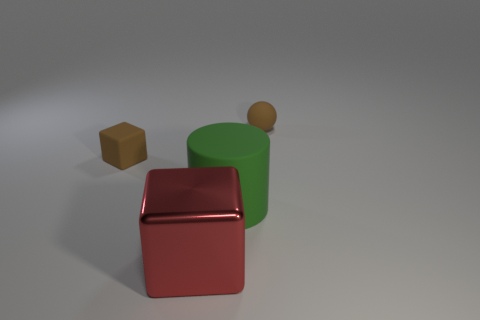There is a matte ball that is the same color as the small matte block; what size is it? The matte ball has a small size, similar to the small matte block's dimensions, showcasing consistency in scale within the objects of similar color. 